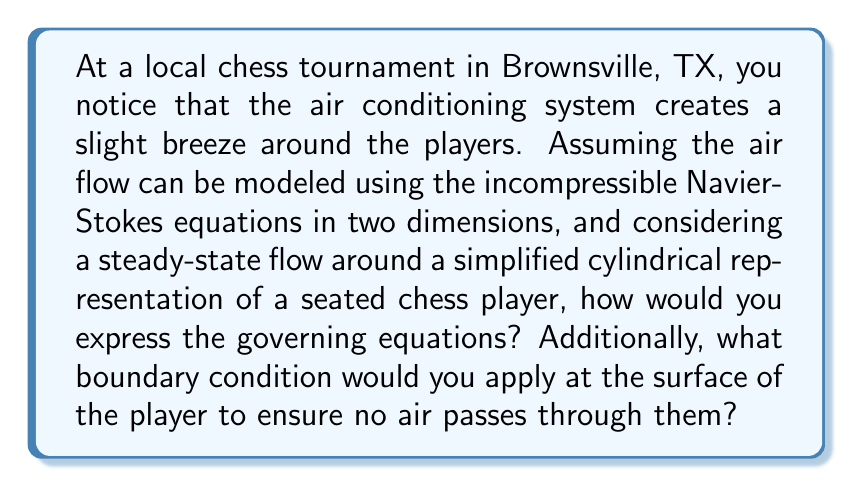Can you answer this question? To model the air flow around a chess player using the Navier-Stokes equations, we need to consider the following:

1. The incompressible Navier-Stokes equations in two dimensions:

For steady-state flow, the equations are:

$$\begin{align}
u\frac{\partial u}{\partial x} + v\frac{\partial u}{\partial y} &= -\frac{1}{\rho}\frac{\partial p}{\partial x} + \nu\left(\frac{\partial^2 u}{\partial x^2} + \frac{\partial^2 u}{\partial y^2}\right) \\
u\frac{\partial v}{\partial x} + v\frac{\partial v}{\partial y} &= -\frac{1}{\rho}\frac{\partial p}{\partial y} + \nu\left(\frac{\partial^2 v}{\partial x^2} + \frac{\partial^2 v}{\partial y^2}\right) \\
\frac{\partial u}{\partial x} + \frac{\partial v}{\partial y} &= 0
\end{align}$$

Where:
- $u$ and $v$ are the x and y components of velocity
- $p$ is pressure
- $\rho$ is density
- $\nu$ is kinematic viscosity

2. Boundary condition at the surface of the player:

To ensure no air passes through the player, we apply the no-slip boundary condition:

$$u = v = 0$$

This condition states that at the surface of the player (represented as a cylinder), both velocity components are zero.

3. Cylindrical representation:

While the equations are given in Cartesian coordinates, it's worth noting that for a cylindrical object, it might be beneficial to transform the equations to polar coordinates. However, this transformation is not required for stating the governing equations and boundary condition.
Answer: The governing equations are the incompressible Navier-Stokes equations in 2D:

$$\begin{align}
u\frac{\partial u}{\partial x} + v\frac{\partial u}{\partial y} &= -\frac{1}{\rho}\frac{\partial p}{\partial x} + \nu\left(\frac{\partial^2 u}{\partial x^2} + \frac{\partial^2 u}{\partial y^2}\right) \\
u\frac{\partial v}{\partial x} + v\frac{\partial v}{\partial y} &= -\frac{1}{\rho}\frac{\partial p}{\partial y} + \nu\left(\frac{\partial^2 v}{\partial x^2} + \frac{\partial^2 v}{\partial y^2}\right) \\
\frac{\partial u}{\partial x} + \frac{\partial v}{\partial y} &= 0
\end{align}$$

The boundary condition at the player's surface is the no-slip condition:

$$u = v = 0$$ 